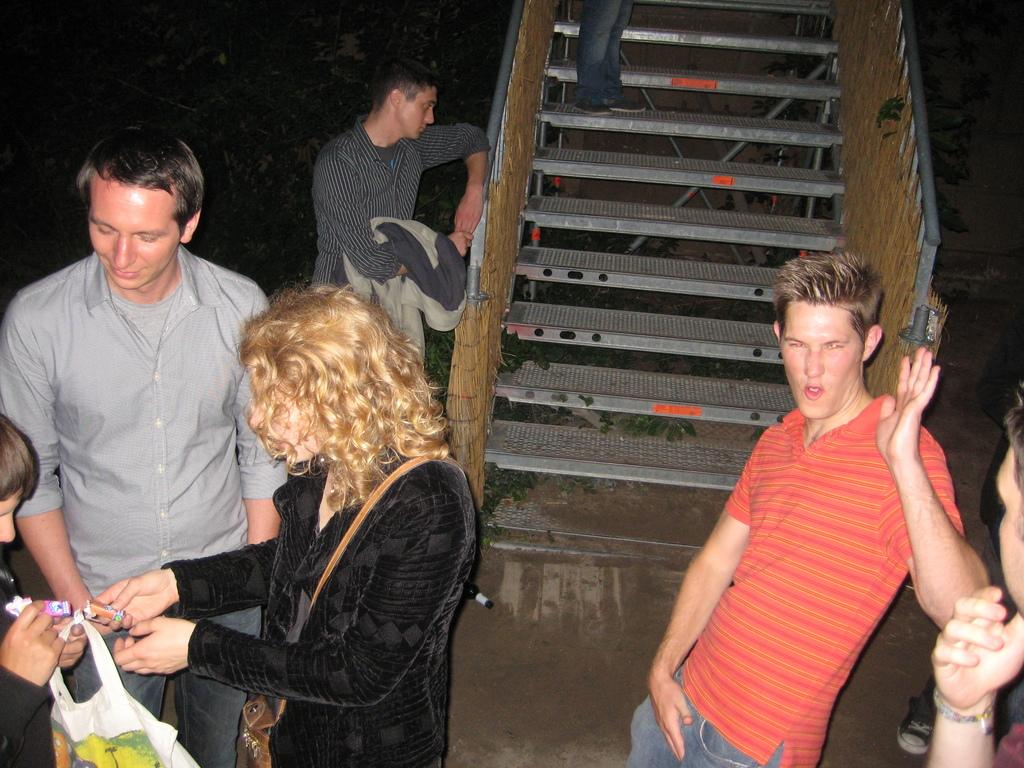How many people are in the image? There are few persons in the image. What is one person holding in the image? One person is holding a plastic cover. Can you describe any architectural feature in the image? Yes, there is a staircase in the image. What is the color of the background in the image? The background of the image is dark. What type of sign can be seen in the image? There is no sign present in the image. What is on the list that the person is holding in the image? There is no list present in the image; one person is holding a plastic cover. 